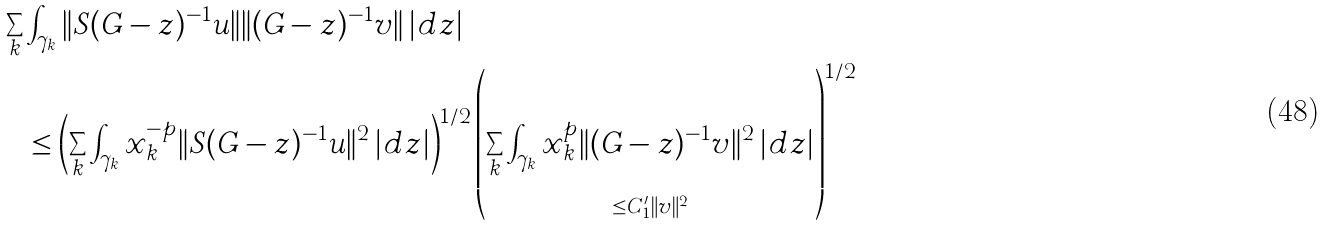<formula> <loc_0><loc_0><loc_500><loc_500>\sum _ { k } & \int _ { \gamma _ { k } } \| S ( G - z ) ^ { - 1 } u \| \| ( G - z ) ^ { - 1 } v \| \, | d z | \\ & \leq \left ( \sum _ { k } \int _ { \gamma _ { k } } x _ { k } ^ { - p } \| S ( G - z ) ^ { - 1 } u \| ^ { 2 } \, | d z | \right ) ^ { 1 / 2 } \left ( \underbrace { \sum _ { k } \int _ { \gamma _ { k } } x _ { k } ^ { p } \| ( G - z ) ^ { - 1 } v \| ^ { 2 } \, | d z | } _ { \leq C _ { 1 } ^ { \prime } \| v \| ^ { 2 } } \right ) ^ { 1 / 2 }</formula> 